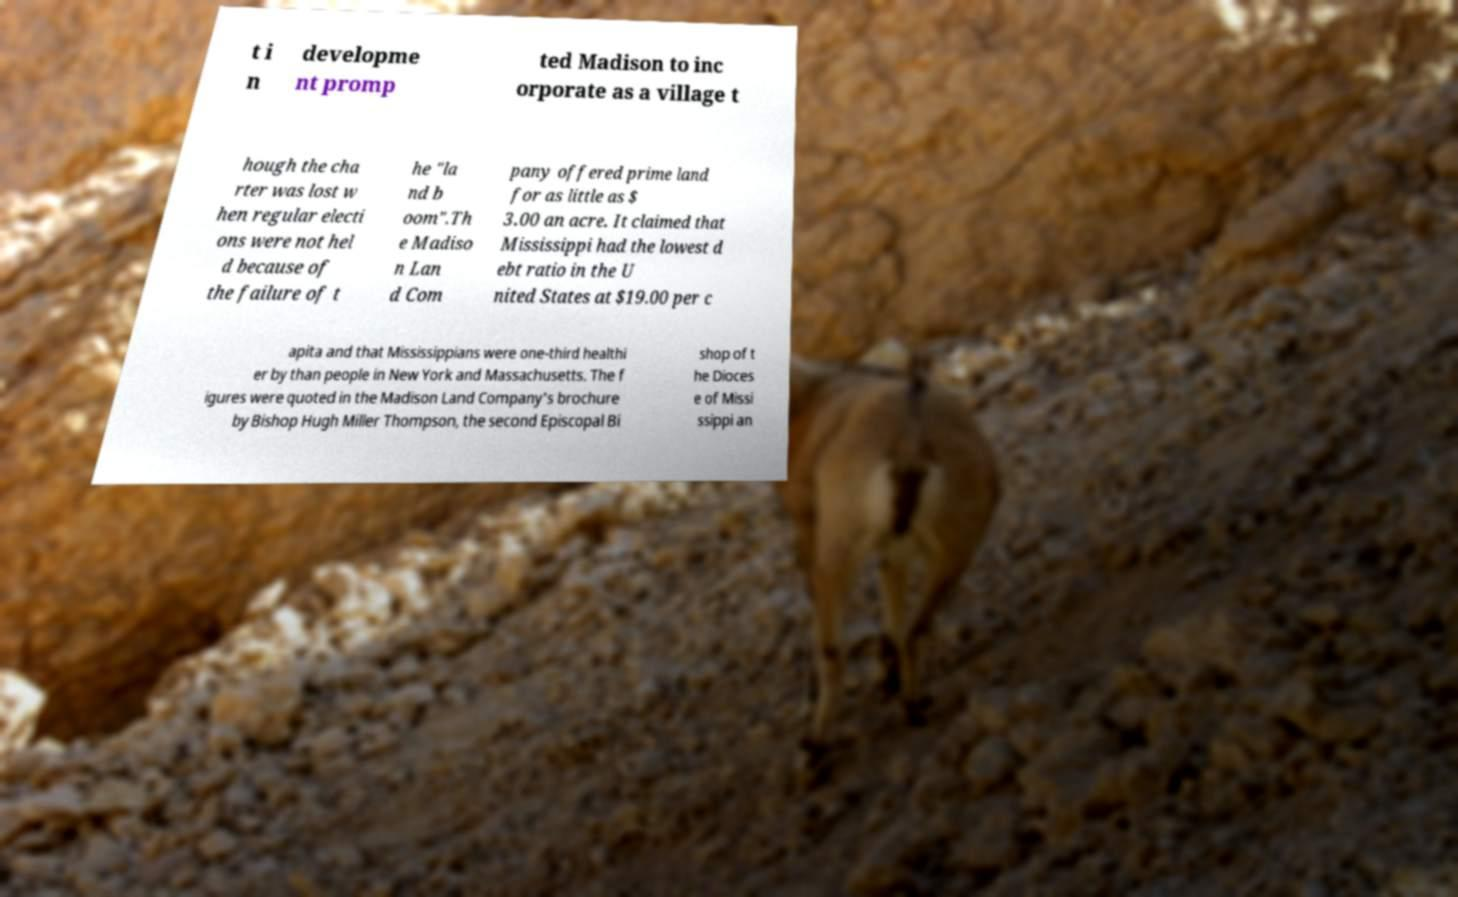Please read and relay the text visible in this image. What does it say? t i n developme nt promp ted Madison to inc orporate as a village t hough the cha rter was lost w hen regular electi ons were not hel d because of the failure of t he "la nd b oom".Th e Madiso n Lan d Com pany offered prime land for as little as $ 3.00 an acre. It claimed that Mississippi had the lowest d ebt ratio in the U nited States at $19.00 per c apita and that Mississippians were one-third healthi er by than people in New York and Massachusetts. The f igures were quoted in the Madison Land Company's brochure by Bishop Hugh Miller Thompson, the second Episcopal Bi shop of t he Dioces e of Missi ssippi an 